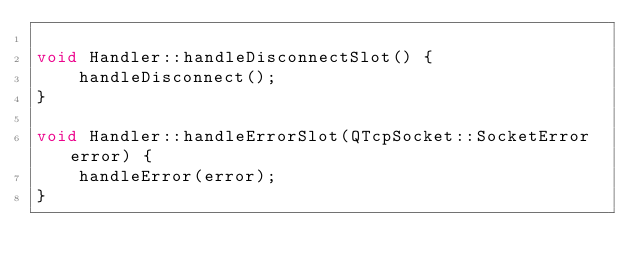Convert code to text. <code><loc_0><loc_0><loc_500><loc_500><_C++_>
void Handler::handleDisconnectSlot() {
    handleDisconnect();
}

void Handler::handleErrorSlot(QTcpSocket::SocketError error) {
    handleError(error);
}
</code> 